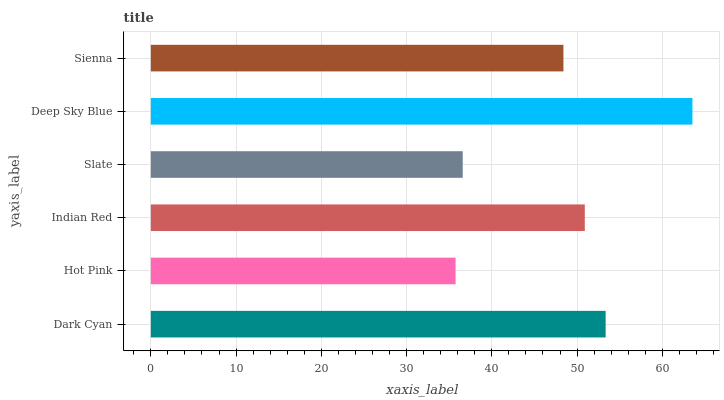Is Hot Pink the minimum?
Answer yes or no. Yes. Is Deep Sky Blue the maximum?
Answer yes or no. Yes. Is Indian Red the minimum?
Answer yes or no. No. Is Indian Red the maximum?
Answer yes or no. No. Is Indian Red greater than Hot Pink?
Answer yes or no. Yes. Is Hot Pink less than Indian Red?
Answer yes or no. Yes. Is Hot Pink greater than Indian Red?
Answer yes or no. No. Is Indian Red less than Hot Pink?
Answer yes or no. No. Is Indian Red the high median?
Answer yes or no. Yes. Is Sienna the low median?
Answer yes or no. Yes. Is Sienna the high median?
Answer yes or no. No. Is Indian Red the low median?
Answer yes or no. No. 